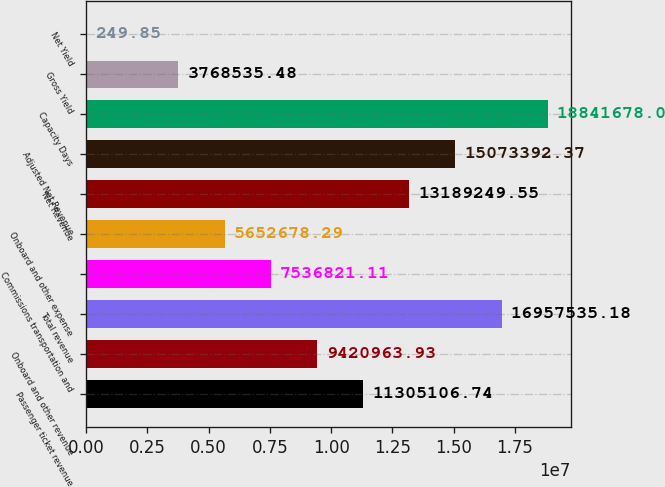Convert chart. <chart><loc_0><loc_0><loc_500><loc_500><bar_chart><fcel>Passenger ticket revenue<fcel>Onboard and other revenue<fcel>Total revenue<fcel>Commissions transportation and<fcel>Onboard and other expense<fcel>Net Revenue<fcel>Adjusted Net Revenue<fcel>Capacity Days<fcel>Gross Yield<fcel>Net Yield<nl><fcel>1.13051e+07<fcel>9.42096e+06<fcel>1.69575e+07<fcel>7.53682e+06<fcel>5.65268e+06<fcel>1.31892e+07<fcel>1.50734e+07<fcel>1.88417e+07<fcel>3.76854e+06<fcel>249.85<nl></chart> 